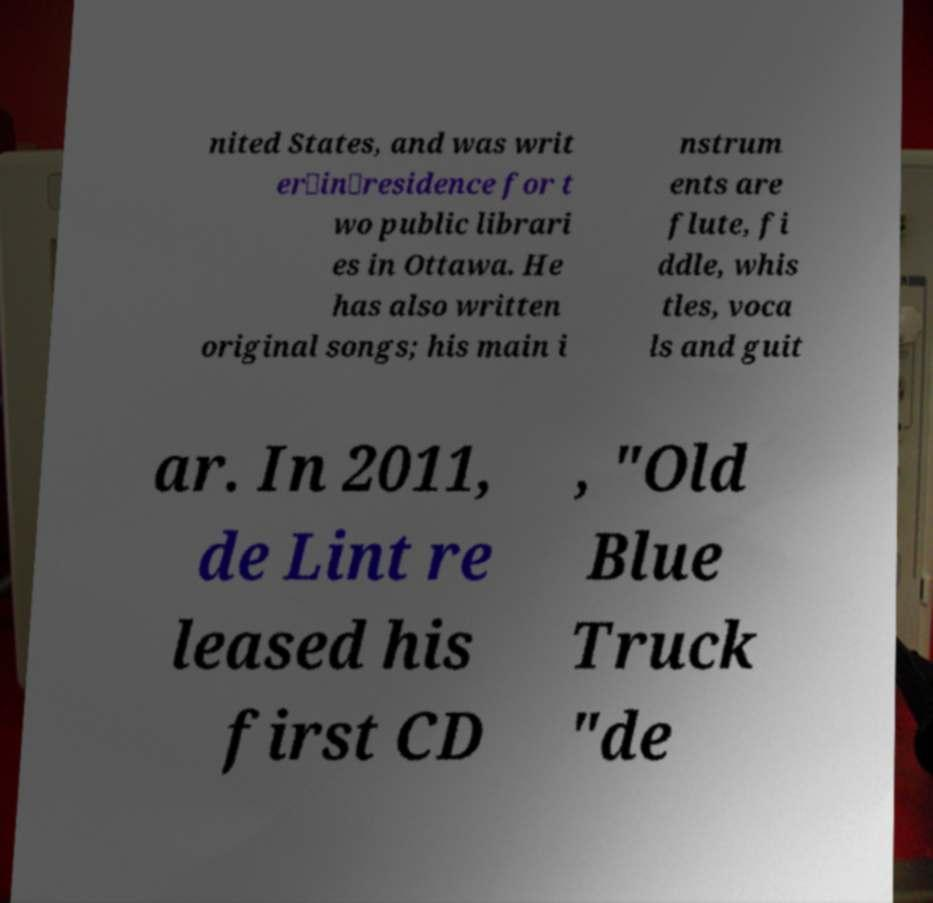What messages or text are displayed in this image? I need them in a readable, typed format. nited States, and was writ er‑in‑residence for t wo public librari es in Ottawa. He has also written original songs; his main i nstrum ents are flute, fi ddle, whis tles, voca ls and guit ar. In 2011, de Lint re leased his first CD , "Old Blue Truck "de 